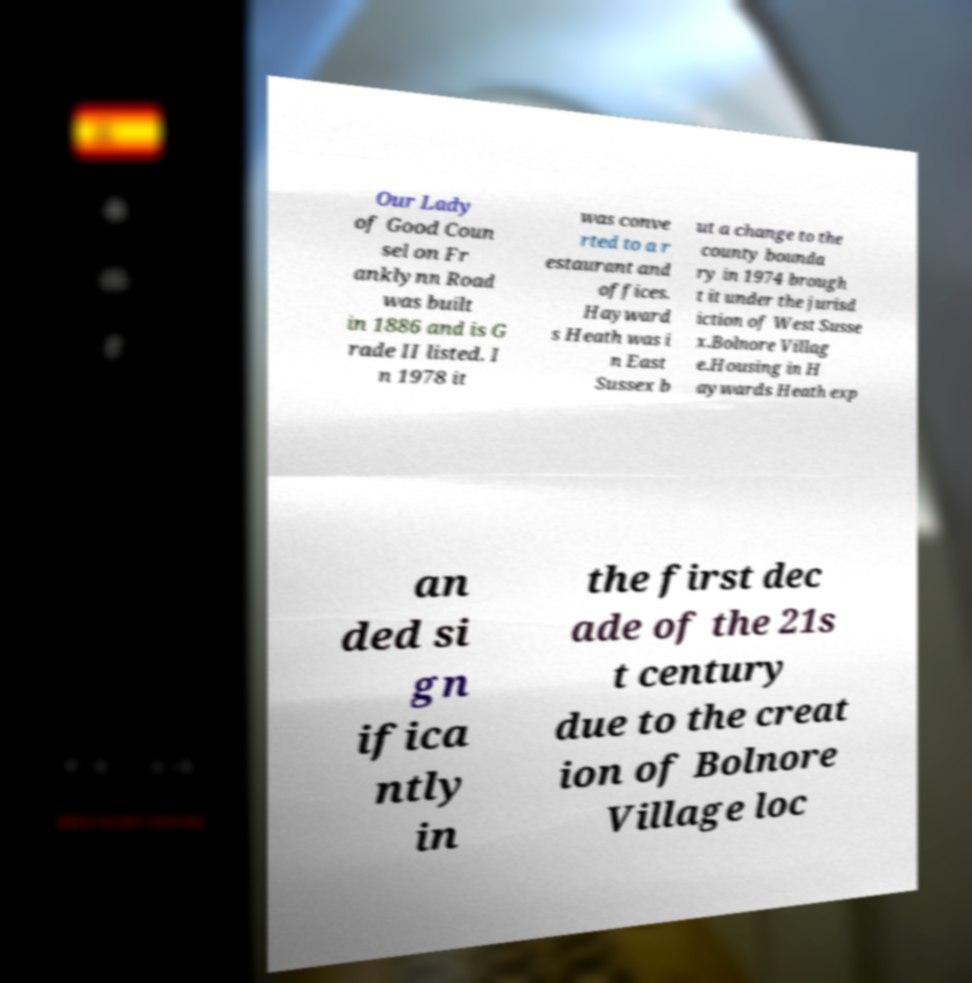Please identify and transcribe the text found in this image. Our Lady of Good Coun sel on Fr anklynn Road was built in 1886 and is G rade II listed. I n 1978 it was conve rted to a r estaurant and offices. Hayward s Heath was i n East Sussex b ut a change to the county bounda ry in 1974 brough t it under the jurisd iction of West Susse x.Bolnore Villag e.Housing in H aywards Heath exp an ded si gn ifica ntly in the first dec ade of the 21s t century due to the creat ion of Bolnore Village loc 